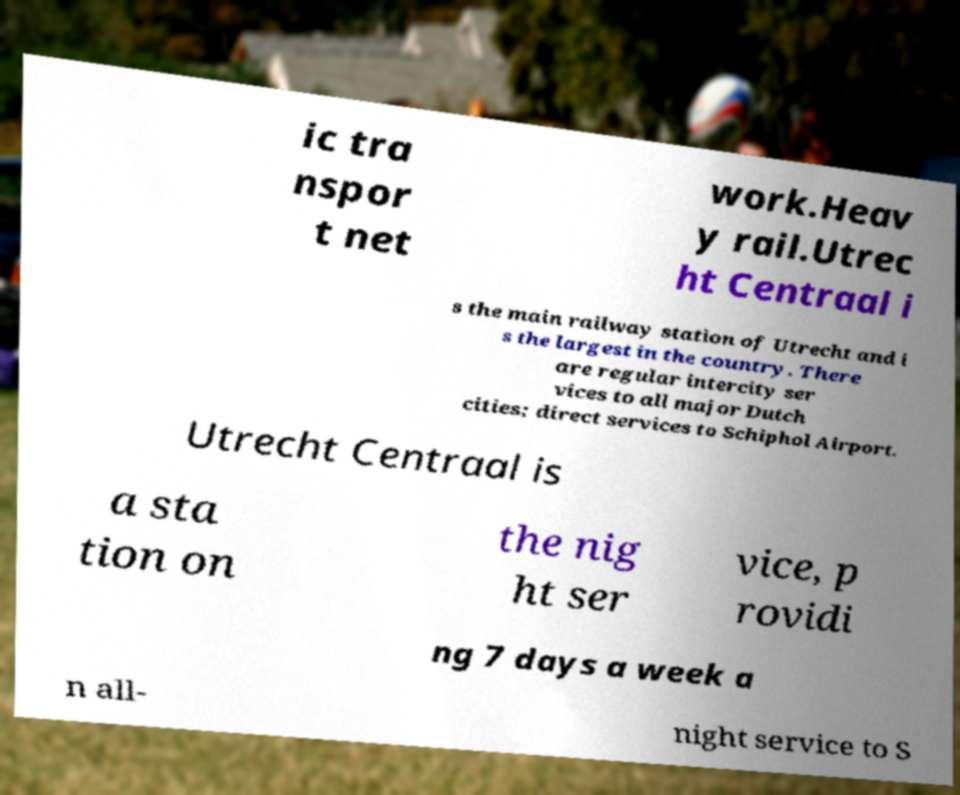There's text embedded in this image that I need extracted. Can you transcribe it verbatim? ic tra nspor t net work.Heav y rail.Utrec ht Centraal i s the main railway station of Utrecht and i s the largest in the country. There are regular intercity ser vices to all major Dutch cities; direct services to Schiphol Airport. Utrecht Centraal is a sta tion on the nig ht ser vice, p rovidi ng 7 days a week a n all- night service to S 